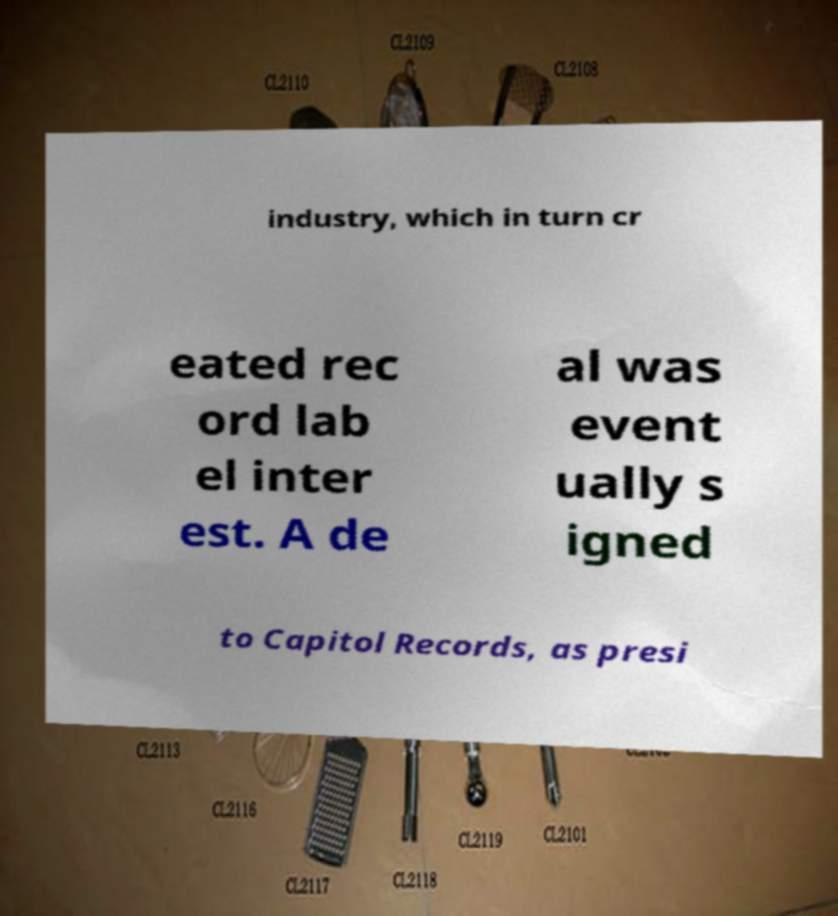Could you assist in decoding the text presented in this image and type it out clearly? industry, which in turn cr eated rec ord lab el inter est. A de al was event ually s igned to Capitol Records, as presi 